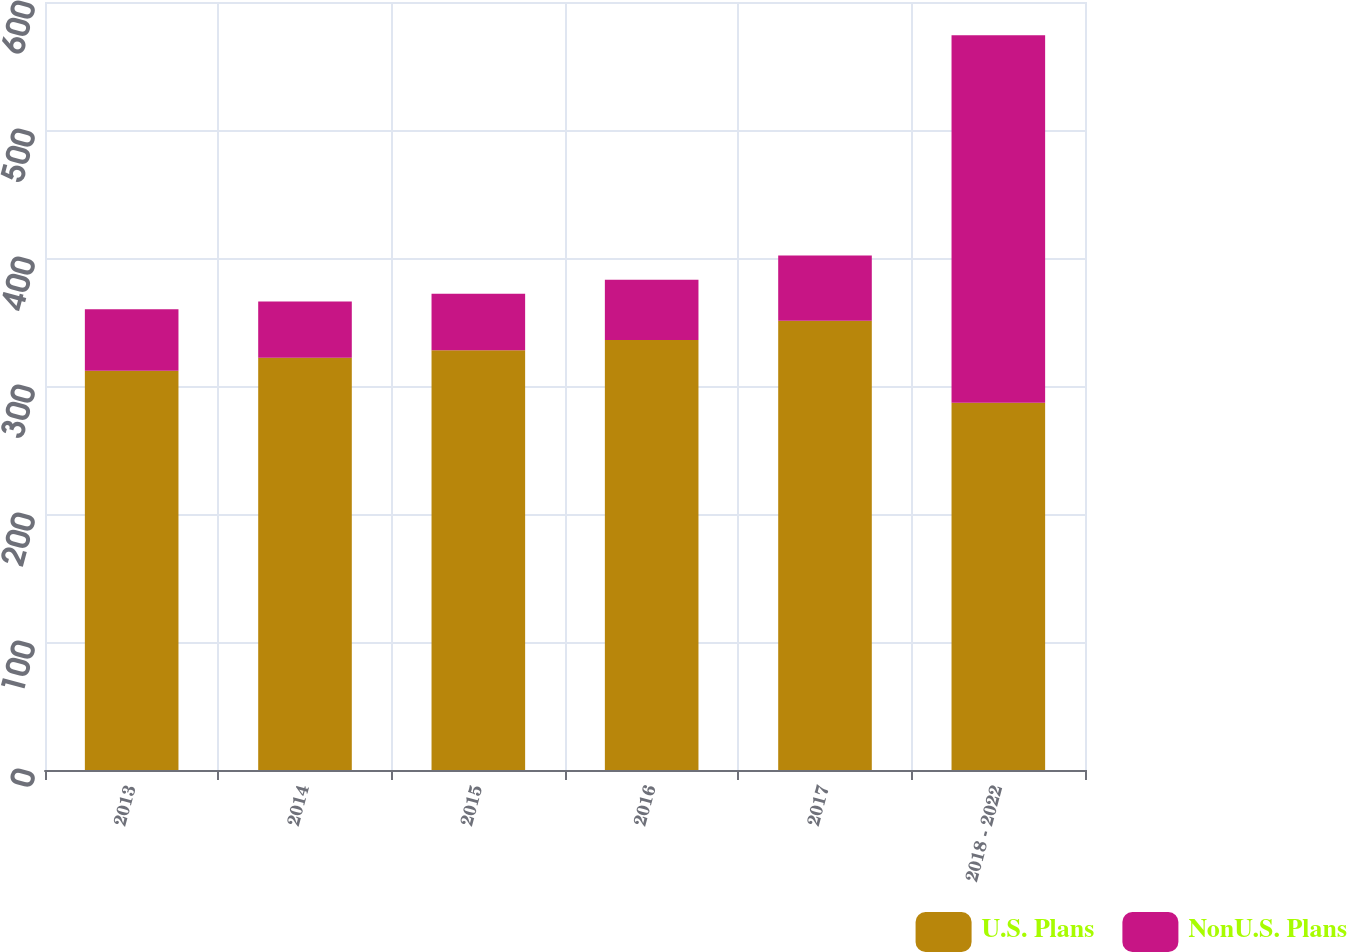Convert chart to OTSL. <chart><loc_0><loc_0><loc_500><loc_500><stacked_bar_chart><ecel><fcel>2013<fcel>2014<fcel>2015<fcel>2016<fcel>2017<fcel>2018 - 2022<nl><fcel>U.S. Plans<fcel>312<fcel>322<fcel>328<fcel>336<fcel>351<fcel>287<nl><fcel>NonU.S. Plans<fcel>48<fcel>44<fcel>44<fcel>47<fcel>51<fcel>287<nl></chart> 